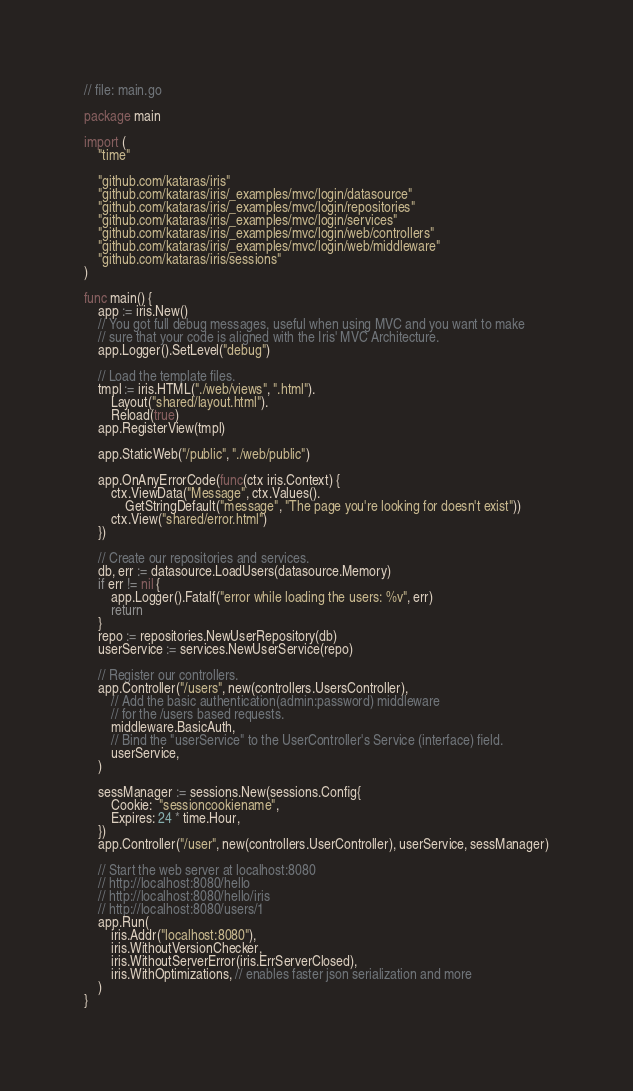<code> <loc_0><loc_0><loc_500><loc_500><_Go_>// file: main.go

package main

import (
	"time"

	"github.com/kataras/iris"
	"github.com/kataras/iris/_examples/mvc/login/datasource"
	"github.com/kataras/iris/_examples/mvc/login/repositories"
	"github.com/kataras/iris/_examples/mvc/login/services"
	"github.com/kataras/iris/_examples/mvc/login/web/controllers"
	"github.com/kataras/iris/_examples/mvc/login/web/middleware"
	"github.com/kataras/iris/sessions"
)

func main() {
	app := iris.New()
	// You got full debug messages, useful when using MVC and you want to make
	// sure that your code is aligned with the Iris' MVC Architecture.
	app.Logger().SetLevel("debug")

	// Load the template files.
	tmpl := iris.HTML("./web/views", ".html").
		Layout("shared/layout.html").
		Reload(true)
	app.RegisterView(tmpl)

	app.StaticWeb("/public", "./web/public")

	app.OnAnyErrorCode(func(ctx iris.Context) {
		ctx.ViewData("Message", ctx.Values().
			GetStringDefault("message", "The page you're looking for doesn't exist"))
		ctx.View("shared/error.html")
	})

	// Create our repositories and services.
	db, err := datasource.LoadUsers(datasource.Memory)
	if err != nil {
		app.Logger().Fatalf("error while loading the users: %v", err)
		return
	}
	repo := repositories.NewUserRepository(db)
	userService := services.NewUserService(repo)

	// Register our controllers.
	app.Controller("/users", new(controllers.UsersController),
		// Add the basic authentication(admin:password) middleware
		// for the /users based requests.
		middleware.BasicAuth,
		// Bind the "userService" to the UserController's Service (interface) field.
		userService,
	)

	sessManager := sessions.New(sessions.Config{
		Cookie:  "sessioncookiename",
		Expires: 24 * time.Hour,
	})
	app.Controller("/user", new(controllers.UserController), userService, sessManager)

	// Start the web server at localhost:8080
	// http://localhost:8080/hello
	// http://localhost:8080/hello/iris
	// http://localhost:8080/users/1
	app.Run(
		iris.Addr("localhost:8080"),
		iris.WithoutVersionChecker,
		iris.WithoutServerError(iris.ErrServerClosed),
		iris.WithOptimizations, // enables faster json serialization and more
	)
}
</code> 